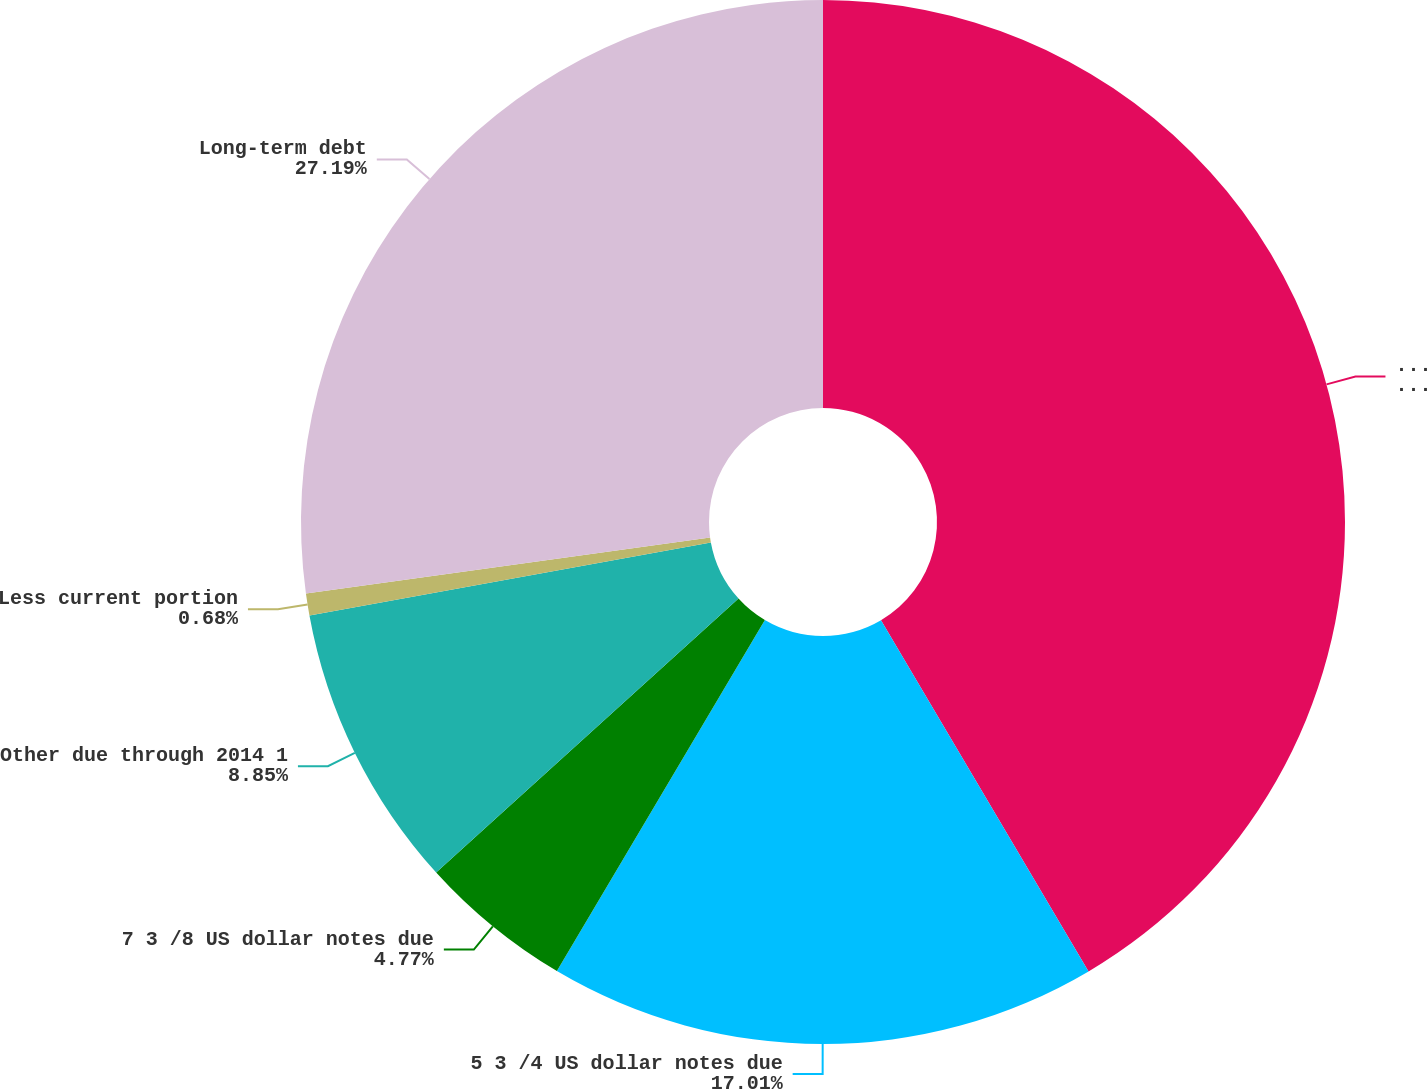<chart> <loc_0><loc_0><loc_500><loc_500><pie_chart><fcel>December 31<fcel>5 3 /4 US dollar notes due<fcel>7 3 /8 US dollar notes due<fcel>Other due through 2014 1<fcel>Less current portion<fcel>Long-term debt<nl><fcel>41.51%<fcel>17.01%<fcel>4.77%<fcel>8.85%<fcel>0.68%<fcel>27.19%<nl></chart> 